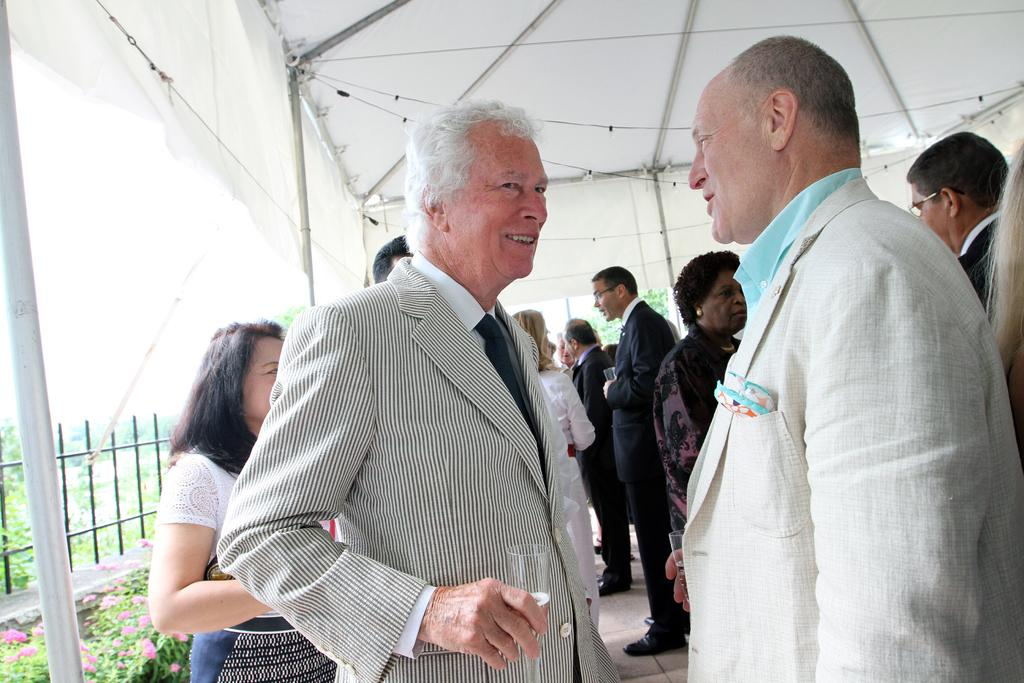What are the persons in the image doing under the tent? The facts do not specify what the persons are doing under the tent. What can be seen on the left side of the image? There is a pole on the left side of the image. What is present in the image that might be used for enclosing an area? There is fencing in the image. What type of vegetation is visible in the bottom left of the image? There are plants in the bottom left of the image. What type of yarn is being used to create the fencing in the image? There is no yarn present in the image; the fencing is made of a different material. 